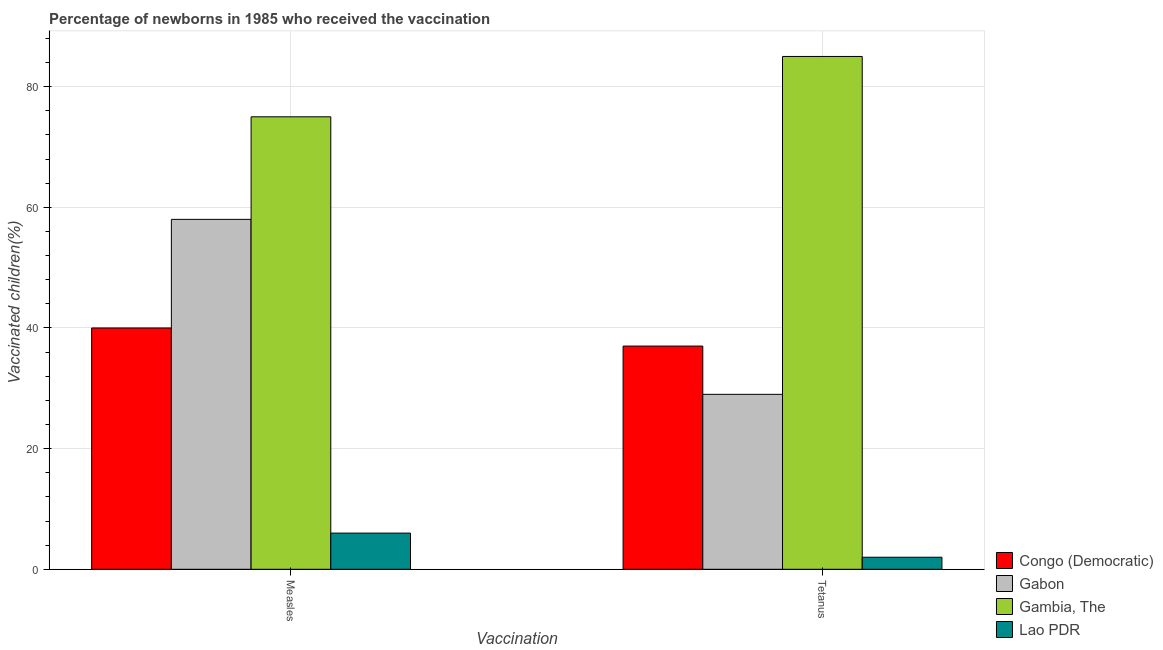Are the number of bars per tick equal to the number of legend labels?
Ensure brevity in your answer.  Yes. How many bars are there on the 1st tick from the left?
Your answer should be very brief. 4. How many bars are there on the 2nd tick from the right?
Make the answer very short. 4. What is the label of the 1st group of bars from the left?
Offer a terse response. Measles. What is the percentage of newborns who received vaccination for measles in Lao PDR?
Your answer should be very brief. 6. Across all countries, what is the maximum percentage of newborns who received vaccination for measles?
Keep it short and to the point. 75. Across all countries, what is the minimum percentage of newborns who received vaccination for tetanus?
Ensure brevity in your answer.  2. In which country was the percentage of newborns who received vaccination for measles maximum?
Provide a short and direct response. Gambia, The. In which country was the percentage of newborns who received vaccination for measles minimum?
Provide a short and direct response. Lao PDR. What is the total percentage of newborns who received vaccination for measles in the graph?
Offer a very short reply. 179. What is the difference between the percentage of newborns who received vaccination for tetanus in Congo (Democratic) and that in Lao PDR?
Keep it short and to the point. 35. What is the difference between the percentage of newborns who received vaccination for measles in Congo (Democratic) and the percentage of newborns who received vaccination for tetanus in Gambia, The?
Keep it short and to the point. -45. What is the average percentage of newborns who received vaccination for tetanus per country?
Provide a short and direct response. 38.25. What is the difference between the percentage of newborns who received vaccination for tetanus and percentage of newborns who received vaccination for measles in Gambia, The?
Your response must be concise. 10. What is the ratio of the percentage of newborns who received vaccination for measles in Gabon to that in Congo (Democratic)?
Your response must be concise. 1.45. What does the 4th bar from the left in Measles represents?
Your response must be concise. Lao PDR. What does the 4th bar from the right in Tetanus represents?
Give a very brief answer. Congo (Democratic). How many bars are there?
Offer a terse response. 8. What is the difference between two consecutive major ticks on the Y-axis?
Your response must be concise. 20. Are the values on the major ticks of Y-axis written in scientific E-notation?
Provide a succinct answer. No. Does the graph contain any zero values?
Make the answer very short. No. Does the graph contain grids?
Offer a very short reply. Yes. How many legend labels are there?
Your answer should be very brief. 4. How are the legend labels stacked?
Ensure brevity in your answer.  Vertical. What is the title of the graph?
Keep it short and to the point. Percentage of newborns in 1985 who received the vaccination. What is the label or title of the X-axis?
Provide a short and direct response. Vaccination. What is the label or title of the Y-axis?
Your answer should be compact. Vaccinated children(%)
. What is the Vaccinated children(%)
 of Gabon in Measles?
Your response must be concise. 58. What is the Vaccinated children(%)
 of Gambia, The in Measles?
Your response must be concise. 75. What is the Vaccinated children(%)
 in Lao PDR in Measles?
Ensure brevity in your answer.  6. What is the Vaccinated children(%)
 of Gabon in Tetanus?
Give a very brief answer. 29. What is the Vaccinated children(%)
 of Gambia, The in Tetanus?
Provide a short and direct response. 85. Across all Vaccination, what is the maximum Vaccinated children(%)
 in Congo (Democratic)?
Offer a very short reply. 40. Across all Vaccination, what is the maximum Vaccinated children(%)
 of Gabon?
Provide a succinct answer. 58. Across all Vaccination, what is the maximum Vaccinated children(%)
 in Gambia, The?
Give a very brief answer. 85. Across all Vaccination, what is the maximum Vaccinated children(%)
 of Lao PDR?
Give a very brief answer. 6. Across all Vaccination, what is the minimum Vaccinated children(%)
 in Gabon?
Offer a very short reply. 29. Across all Vaccination, what is the minimum Vaccinated children(%)
 in Lao PDR?
Give a very brief answer. 2. What is the total Vaccinated children(%)
 of Congo (Democratic) in the graph?
Give a very brief answer. 77. What is the total Vaccinated children(%)
 of Gambia, The in the graph?
Provide a succinct answer. 160. What is the total Vaccinated children(%)
 in Lao PDR in the graph?
Your answer should be very brief. 8. What is the difference between the Vaccinated children(%)
 of Gabon in Measles and that in Tetanus?
Give a very brief answer. 29. What is the difference between the Vaccinated children(%)
 in Gambia, The in Measles and that in Tetanus?
Ensure brevity in your answer.  -10. What is the difference between the Vaccinated children(%)
 of Congo (Democratic) in Measles and the Vaccinated children(%)
 of Gambia, The in Tetanus?
Offer a terse response. -45. What is the difference between the Vaccinated children(%)
 of Gabon in Measles and the Vaccinated children(%)
 of Gambia, The in Tetanus?
Offer a very short reply. -27. What is the difference between the Vaccinated children(%)
 of Gabon in Measles and the Vaccinated children(%)
 of Lao PDR in Tetanus?
Your answer should be very brief. 56. What is the difference between the Vaccinated children(%)
 in Gambia, The in Measles and the Vaccinated children(%)
 in Lao PDR in Tetanus?
Provide a succinct answer. 73. What is the average Vaccinated children(%)
 in Congo (Democratic) per Vaccination?
Your answer should be compact. 38.5. What is the average Vaccinated children(%)
 of Gabon per Vaccination?
Your response must be concise. 43.5. What is the average Vaccinated children(%)
 of Lao PDR per Vaccination?
Your response must be concise. 4. What is the difference between the Vaccinated children(%)
 of Congo (Democratic) and Vaccinated children(%)
 of Gambia, The in Measles?
Make the answer very short. -35. What is the difference between the Vaccinated children(%)
 of Gabon and Vaccinated children(%)
 of Lao PDR in Measles?
Keep it short and to the point. 52. What is the difference between the Vaccinated children(%)
 of Gambia, The and Vaccinated children(%)
 of Lao PDR in Measles?
Provide a succinct answer. 69. What is the difference between the Vaccinated children(%)
 of Congo (Democratic) and Vaccinated children(%)
 of Gambia, The in Tetanus?
Provide a short and direct response. -48. What is the difference between the Vaccinated children(%)
 of Congo (Democratic) and Vaccinated children(%)
 of Lao PDR in Tetanus?
Offer a very short reply. 35. What is the difference between the Vaccinated children(%)
 in Gabon and Vaccinated children(%)
 in Gambia, The in Tetanus?
Make the answer very short. -56. What is the difference between the Vaccinated children(%)
 of Gabon and Vaccinated children(%)
 of Lao PDR in Tetanus?
Your answer should be very brief. 27. What is the ratio of the Vaccinated children(%)
 of Congo (Democratic) in Measles to that in Tetanus?
Ensure brevity in your answer.  1.08. What is the ratio of the Vaccinated children(%)
 of Gabon in Measles to that in Tetanus?
Offer a terse response. 2. What is the ratio of the Vaccinated children(%)
 of Gambia, The in Measles to that in Tetanus?
Your answer should be compact. 0.88. What is the difference between the highest and the second highest Vaccinated children(%)
 in Gambia, The?
Your response must be concise. 10. What is the difference between the highest and the second highest Vaccinated children(%)
 in Lao PDR?
Offer a very short reply. 4. What is the difference between the highest and the lowest Vaccinated children(%)
 of Gabon?
Give a very brief answer. 29. What is the difference between the highest and the lowest Vaccinated children(%)
 in Gambia, The?
Offer a very short reply. 10. 